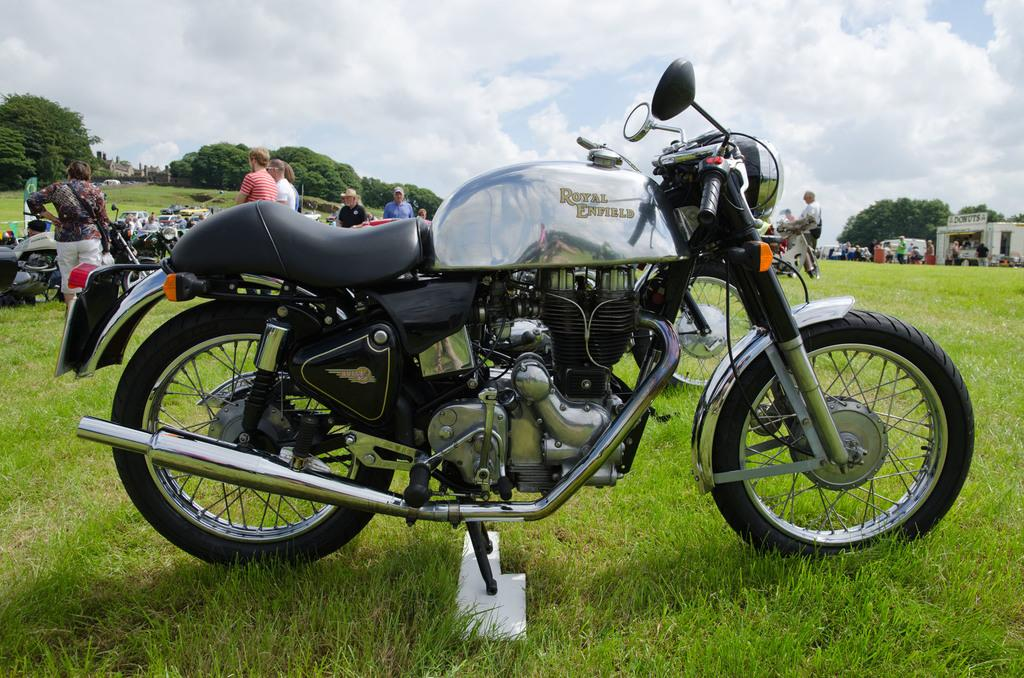What is the main subject in the center of the image? There is a bike in the center of the image. What can be seen in the background of the image? There are persons, trees, buildings, and the sky visible in the background of the image. What type of vegetation is present in the image? There is grass at the bottom of the image. What is the condition of the sky in the image? The sky is visible in the background of the image, and clouds are present. What knowledge does the father possess in the image? There is no father present in the image, and therefore no knowledge to discuss. What achievements has the achiever accomplished in the image? There is no achiever present in the image, and therefore no achievements to discuss. 